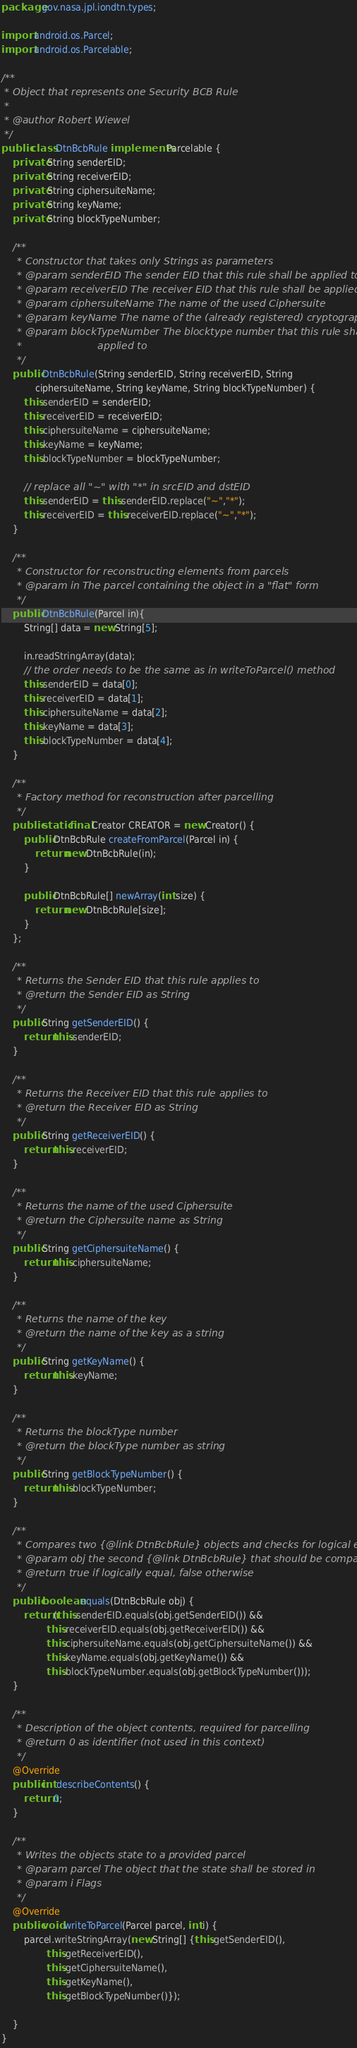Convert code to text. <code><loc_0><loc_0><loc_500><loc_500><_Java_>package gov.nasa.jpl.iondtn.types;

import android.os.Parcel;
import android.os.Parcelable;

/**
 * Object that represents one Security BCB Rule
 *
 * @author Robert Wiewel
 */
public class DtnBcbRule implements Parcelable {
    private String senderEID;
    private String receiverEID;
    private String ciphersuiteName;
    private String keyName;
    private String blockTypeNumber;

    /**
     * Constructor that takes only Strings as parameters
     * @param senderEID The sender EID that this rule shall be applied to
     * @param receiverEID The receiver EID that this rule shall be applied to
     * @param ciphersuiteName The name of the used Ciphersuite
     * @param keyName The name of the (already registered) cryptographic key
     * @param blockTypeNumber The blocktype number that this rule shall be
     *                        applied to
     */
    public DtnBcbRule(String senderEID, String receiverEID, String
            ciphersuiteName, String keyName, String blockTypeNumber) {
        this.senderEID = senderEID;
        this.receiverEID = receiverEID;
        this.ciphersuiteName = ciphersuiteName;
        this.keyName = keyName;
        this.blockTypeNumber = blockTypeNumber;

        // replace all "~" with "*" in srcEID and dstEID
        this.senderEID = this.senderEID.replace("~","*");
        this.receiverEID = this.receiverEID.replace("~","*");
    }

    /**
     * Constructor for reconstructing elements from parcels
     * @param in The parcel containing the object in a "flat" form
     */
    public DtnBcbRule(Parcel in){
        String[] data = new String[5];

        in.readStringArray(data);
        // the order needs to be the same as in writeToParcel() method
        this.senderEID = data[0];
        this.receiverEID = data[1];
        this.ciphersuiteName = data[2];
        this.keyName = data[3];
        this.blockTypeNumber = data[4];
    }

    /**
     * Factory method for reconstruction after parcelling
     */
    public static final Creator CREATOR = new Creator() {
        public DtnBcbRule createFromParcel(Parcel in) {
            return new DtnBcbRule(in);
        }

        public DtnBcbRule[] newArray(int size) {
            return new DtnBcbRule[size];
        }
    };

    /**
     * Returns the Sender EID that this rule applies to
     * @return the Sender EID as String
     */
    public String getSenderEID() {
        return this.senderEID;
    }

    /**
     * Returns the Receiver EID that this rule applies to
     * @return the Receiver EID as String
     */
    public String getReceiverEID() {
        return this.receiverEID;
    }

    /**
     * Returns the name of the used Ciphersuite
     * @return the Ciphersuite name as String
     */
    public String getCiphersuiteName() {
        return this.ciphersuiteName;
    }

    /**
     * Returns the name of the key
     * @return the name of the key as a string
     */
    public String getKeyName() {
        return this.keyName;
    }

    /**
     * Returns the blockType number
     * @return the blockType number as string
     */
    public String getBlockTypeNumber() {
        return this.blockTypeNumber;
    }

    /**
     * Compares two {@link DtnBcbRule} objects and checks for logical equality
     * @param obj the second {@link DtnBcbRule} that should be compared to
     * @return true if logically equal, false otherwise
     */
    public boolean equals(DtnBcbRule obj) {
        return (this.senderEID.equals(obj.getSenderEID()) &&
                this.receiverEID.equals(obj.getReceiverEID()) &&
                this.ciphersuiteName.equals(obj.getCiphersuiteName()) &&
                this.keyName.equals(obj.getKeyName()) &&
                this.blockTypeNumber.equals(obj.getBlockTypeNumber()));
    }

    /**
     * Description of the object contents, required for parcelling
     * @return 0 as identifier (not used in this context)
     */
    @Override
    public int describeContents() {
        return 0;
    }

    /**
     * Writes the objects state to a provided parcel
     * @param parcel The object that the state shall be stored in
     * @param i Flags
     */
    @Override
    public void writeToParcel(Parcel parcel, int i) {
        parcel.writeStringArray(new String[] {this.getSenderEID(),
                this.getReceiverEID(),
                this.getCiphersuiteName(),
                this.getKeyName(),
                this.getBlockTypeNumber()});

    }
}
</code> 